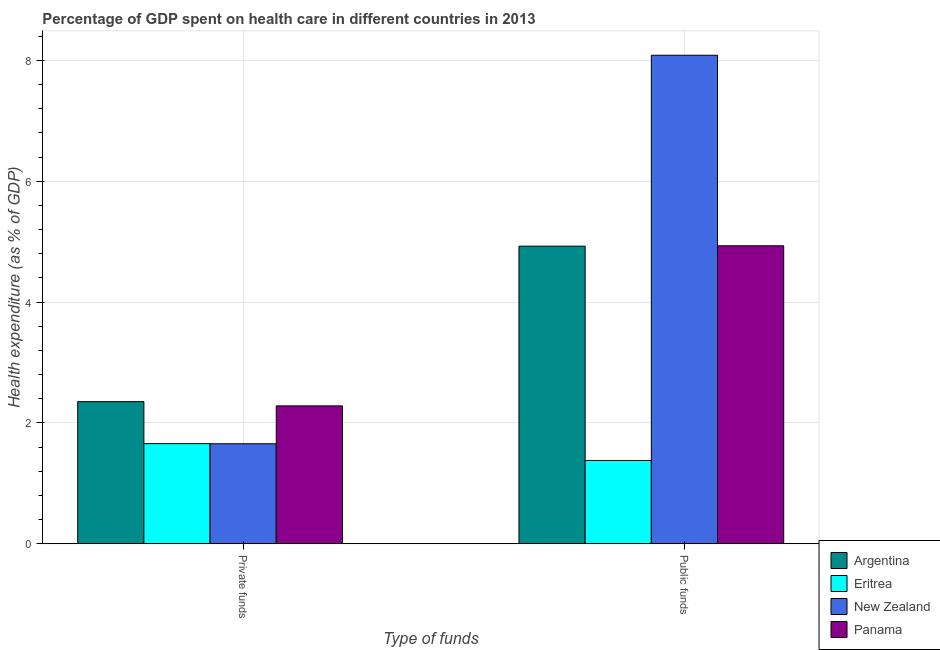How many different coloured bars are there?
Your response must be concise. 4. How many groups of bars are there?
Ensure brevity in your answer.  2. Are the number of bars per tick equal to the number of legend labels?
Provide a succinct answer. Yes. How many bars are there on the 1st tick from the right?
Offer a very short reply. 4. What is the label of the 2nd group of bars from the left?
Ensure brevity in your answer.  Public funds. What is the amount of private funds spent in healthcare in Argentina?
Make the answer very short. 2.35. Across all countries, what is the maximum amount of private funds spent in healthcare?
Offer a terse response. 2.35. Across all countries, what is the minimum amount of public funds spent in healthcare?
Your response must be concise. 1.38. In which country was the amount of public funds spent in healthcare maximum?
Your answer should be very brief. New Zealand. In which country was the amount of private funds spent in healthcare minimum?
Offer a terse response. New Zealand. What is the total amount of private funds spent in healthcare in the graph?
Provide a succinct answer. 7.95. What is the difference between the amount of public funds spent in healthcare in New Zealand and that in Panama?
Offer a very short reply. 3.15. What is the difference between the amount of private funds spent in healthcare in Eritrea and the amount of public funds spent in healthcare in Argentina?
Make the answer very short. -3.27. What is the average amount of public funds spent in healthcare per country?
Provide a succinct answer. 4.83. What is the difference between the amount of private funds spent in healthcare and amount of public funds spent in healthcare in Panama?
Provide a succinct answer. -2.65. What is the ratio of the amount of private funds spent in healthcare in Eritrea to that in Panama?
Your response must be concise. 0.73. In how many countries, is the amount of private funds spent in healthcare greater than the average amount of private funds spent in healthcare taken over all countries?
Provide a short and direct response. 2. What does the 2nd bar from the left in Public funds represents?
Provide a succinct answer. Eritrea. What does the 4th bar from the right in Private funds represents?
Give a very brief answer. Argentina. How many countries are there in the graph?
Ensure brevity in your answer.  4. What is the difference between two consecutive major ticks on the Y-axis?
Offer a very short reply. 2. Are the values on the major ticks of Y-axis written in scientific E-notation?
Provide a short and direct response. No. Does the graph contain any zero values?
Your answer should be compact. No. Where does the legend appear in the graph?
Your response must be concise. Bottom right. How many legend labels are there?
Offer a very short reply. 4. What is the title of the graph?
Give a very brief answer. Percentage of GDP spent on health care in different countries in 2013. Does "Egypt, Arab Rep." appear as one of the legend labels in the graph?
Keep it short and to the point. No. What is the label or title of the X-axis?
Your answer should be compact. Type of funds. What is the label or title of the Y-axis?
Your answer should be compact. Health expenditure (as % of GDP). What is the Health expenditure (as % of GDP) of Argentina in Private funds?
Offer a very short reply. 2.35. What is the Health expenditure (as % of GDP) in Eritrea in Private funds?
Ensure brevity in your answer.  1.66. What is the Health expenditure (as % of GDP) in New Zealand in Private funds?
Offer a terse response. 1.66. What is the Health expenditure (as % of GDP) in Panama in Private funds?
Your answer should be very brief. 2.28. What is the Health expenditure (as % of GDP) in Argentina in Public funds?
Ensure brevity in your answer.  4.92. What is the Health expenditure (as % of GDP) of Eritrea in Public funds?
Ensure brevity in your answer.  1.38. What is the Health expenditure (as % of GDP) of New Zealand in Public funds?
Your response must be concise. 8.08. What is the Health expenditure (as % of GDP) in Panama in Public funds?
Your response must be concise. 4.93. Across all Type of funds, what is the maximum Health expenditure (as % of GDP) of Argentina?
Keep it short and to the point. 4.92. Across all Type of funds, what is the maximum Health expenditure (as % of GDP) in Eritrea?
Ensure brevity in your answer.  1.66. Across all Type of funds, what is the maximum Health expenditure (as % of GDP) in New Zealand?
Provide a short and direct response. 8.08. Across all Type of funds, what is the maximum Health expenditure (as % of GDP) of Panama?
Keep it short and to the point. 4.93. Across all Type of funds, what is the minimum Health expenditure (as % of GDP) of Argentina?
Provide a short and direct response. 2.35. Across all Type of funds, what is the minimum Health expenditure (as % of GDP) in Eritrea?
Your answer should be very brief. 1.38. Across all Type of funds, what is the minimum Health expenditure (as % of GDP) of New Zealand?
Offer a terse response. 1.66. Across all Type of funds, what is the minimum Health expenditure (as % of GDP) of Panama?
Make the answer very short. 2.28. What is the total Health expenditure (as % of GDP) in Argentina in the graph?
Offer a very short reply. 7.28. What is the total Health expenditure (as % of GDP) of Eritrea in the graph?
Give a very brief answer. 3.04. What is the total Health expenditure (as % of GDP) in New Zealand in the graph?
Ensure brevity in your answer.  9.74. What is the total Health expenditure (as % of GDP) in Panama in the graph?
Offer a terse response. 7.21. What is the difference between the Health expenditure (as % of GDP) in Argentina in Private funds and that in Public funds?
Your answer should be compact. -2.57. What is the difference between the Health expenditure (as % of GDP) in Eritrea in Private funds and that in Public funds?
Provide a succinct answer. 0.28. What is the difference between the Health expenditure (as % of GDP) of New Zealand in Private funds and that in Public funds?
Make the answer very short. -6.43. What is the difference between the Health expenditure (as % of GDP) in Panama in Private funds and that in Public funds?
Offer a terse response. -2.65. What is the difference between the Health expenditure (as % of GDP) in Argentina in Private funds and the Health expenditure (as % of GDP) in Eritrea in Public funds?
Provide a short and direct response. 0.97. What is the difference between the Health expenditure (as % of GDP) in Argentina in Private funds and the Health expenditure (as % of GDP) in New Zealand in Public funds?
Provide a succinct answer. -5.73. What is the difference between the Health expenditure (as % of GDP) in Argentina in Private funds and the Health expenditure (as % of GDP) in Panama in Public funds?
Provide a succinct answer. -2.58. What is the difference between the Health expenditure (as % of GDP) of Eritrea in Private funds and the Health expenditure (as % of GDP) of New Zealand in Public funds?
Your answer should be very brief. -6.43. What is the difference between the Health expenditure (as % of GDP) of Eritrea in Private funds and the Health expenditure (as % of GDP) of Panama in Public funds?
Keep it short and to the point. -3.27. What is the difference between the Health expenditure (as % of GDP) of New Zealand in Private funds and the Health expenditure (as % of GDP) of Panama in Public funds?
Your answer should be compact. -3.28. What is the average Health expenditure (as % of GDP) in Argentina per Type of funds?
Provide a succinct answer. 3.64. What is the average Health expenditure (as % of GDP) of Eritrea per Type of funds?
Your answer should be compact. 1.52. What is the average Health expenditure (as % of GDP) in New Zealand per Type of funds?
Your answer should be compact. 4.87. What is the average Health expenditure (as % of GDP) in Panama per Type of funds?
Provide a short and direct response. 3.61. What is the difference between the Health expenditure (as % of GDP) of Argentina and Health expenditure (as % of GDP) of Eritrea in Private funds?
Your response must be concise. 0.69. What is the difference between the Health expenditure (as % of GDP) of Argentina and Health expenditure (as % of GDP) of New Zealand in Private funds?
Your response must be concise. 0.7. What is the difference between the Health expenditure (as % of GDP) in Argentina and Health expenditure (as % of GDP) in Panama in Private funds?
Make the answer very short. 0.07. What is the difference between the Health expenditure (as % of GDP) in Eritrea and Health expenditure (as % of GDP) in New Zealand in Private funds?
Keep it short and to the point. 0. What is the difference between the Health expenditure (as % of GDP) in Eritrea and Health expenditure (as % of GDP) in Panama in Private funds?
Provide a short and direct response. -0.62. What is the difference between the Health expenditure (as % of GDP) of New Zealand and Health expenditure (as % of GDP) of Panama in Private funds?
Your answer should be very brief. -0.63. What is the difference between the Health expenditure (as % of GDP) in Argentina and Health expenditure (as % of GDP) in Eritrea in Public funds?
Offer a very short reply. 3.55. What is the difference between the Health expenditure (as % of GDP) of Argentina and Health expenditure (as % of GDP) of New Zealand in Public funds?
Offer a terse response. -3.16. What is the difference between the Health expenditure (as % of GDP) in Argentina and Health expenditure (as % of GDP) in Panama in Public funds?
Give a very brief answer. -0.01. What is the difference between the Health expenditure (as % of GDP) of Eritrea and Health expenditure (as % of GDP) of New Zealand in Public funds?
Give a very brief answer. -6.71. What is the difference between the Health expenditure (as % of GDP) of Eritrea and Health expenditure (as % of GDP) of Panama in Public funds?
Provide a short and direct response. -3.55. What is the difference between the Health expenditure (as % of GDP) in New Zealand and Health expenditure (as % of GDP) in Panama in Public funds?
Your answer should be compact. 3.15. What is the ratio of the Health expenditure (as % of GDP) of Argentina in Private funds to that in Public funds?
Make the answer very short. 0.48. What is the ratio of the Health expenditure (as % of GDP) in Eritrea in Private funds to that in Public funds?
Keep it short and to the point. 1.2. What is the ratio of the Health expenditure (as % of GDP) in New Zealand in Private funds to that in Public funds?
Ensure brevity in your answer.  0.2. What is the ratio of the Health expenditure (as % of GDP) of Panama in Private funds to that in Public funds?
Keep it short and to the point. 0.46. What is the difference between the highest and the second highest Health expenditure (as % of GDP) in Argentina?
Make the answer very short. 2.57. What is the difference between the highest and the second highest Health expenditure (as % of GDP) in Eritrea?
Your answer should be very brief. 0.28. What is the difference between the highest and the second highest Health expenditure (as % of GDP) of New Zealand?
Make the answer very short. 6.43. What is the difference between the highest and the second highest Health expenditure (as % of GDP) of Panama?
Offer a terse response. 2.65. What is the difference between the highest and the lowest Health expenditure (as % of GDP) of Argentina?
Your answer should be compact. 2.57. What is the difference between the highest and the lowest Health expenditure (as % of GDP) of Eritrea?
Provide a short and direct response. 0.28. What is the difference between the highest and the lowest Health expenditure (as % of GDP) in New Zealand?
Your answer should be very brief. 6.43. What is the difference between the highest and the lowest Health expenditure (as % of GDP) of Panama?
Ensure brevity in your answer.  2.65. 